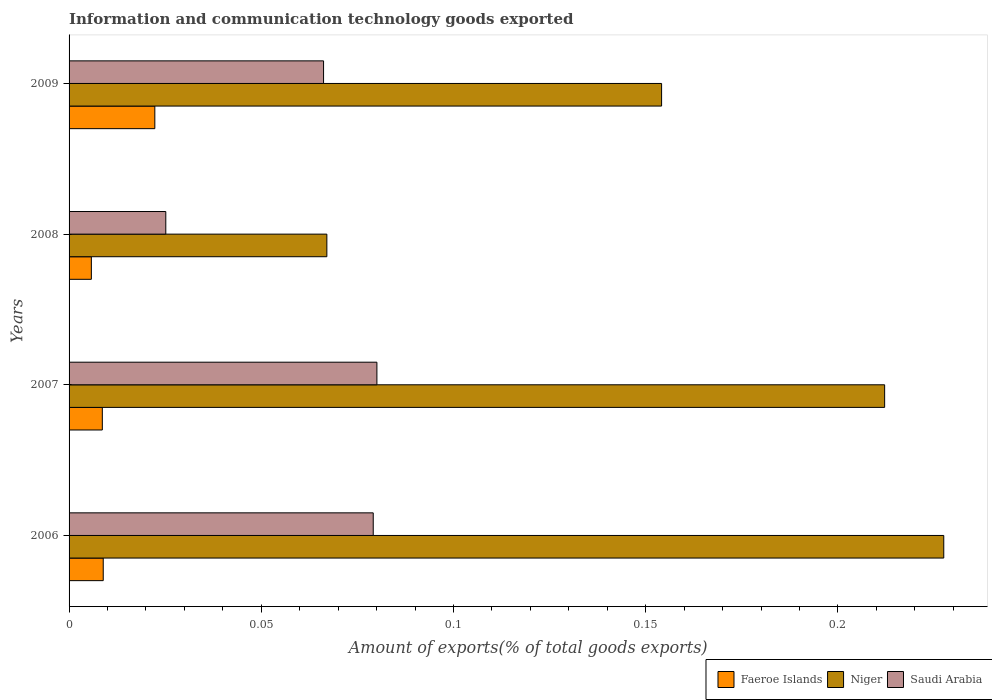How many different coloured bars are there?
Give a very brief answer. 3. Are the number of bars per tick equal to the number of legend labels?
Ensure brevity in your answer.  Yes. Are the number of bars on each tick of the Y-axis equal?
Keep it short and to the point. Yes. What is the label of the 2nd group of bars from the top?
Ensure brevity in your answer.  2008. What is the amount of goods exported in Niger in 2008?
Keep it short and to the point. 0.07. Across all years, what is the maximum amount of goods exported in Niger?
Your response must be concise. 0.23. Across all years, what is the minimum amount of goods exported in Niger?
Keep it short and to the point. 0.07. In which year was the amount of goods exported in Saudi Arabia minimum?
Give a very brief answer. 2008. What is the total amount of goods exported in Saudi Arabia in the graph?
Provide a short and direct response. 0.25. What is the difference between the amount of goods exported in Saudi Arabia in 2007 and that in 2009?
Your answer should be very brief. 0.01. What is the difference between the amount of goods exported in Niger in 2009 and the amount of goods exported in Faeroe Islands in 2007?
Your answer should be very brief. 0.15. What is the average amount of goods exported in Niger per year?
Your answer should be very brief. 0.17. In the year 2007, what is the difference between the amount of goods exported in Niger and amount of goods exported in Saudi Arabia?
Keep it short and to the point. 0.13. In how many years, is the amount of goods exported in Saudi Arabia greater than 0.07 %?
Offer a terse response. 2. What is the ratio of the amount of goods exported in Saudi Arabia in 2006 to that in 2009?
Make the answer very short. 1.2. What is the difference between the highest and the second highest amount of goods exported in Niger?
Make the answer very short. 0.02. What is the difference between the highest and the lowest amount of goods exported in Faeroe Islands?
Make the answer very short. 0.02. In how many years, is the amount of goods exported in Niger greater than the average amount of goods exported in Niger taken over all years?
Provide a succinct answer. 2. Is the sum of the amount of goods exported in Niger in 2006 and 2007 greater than the maximum amount of goods exported in Saudi Arabia across all years?
Your answer should be compact. Yes. What does the 3rd bar from the top in 2008 represents?
Give a very brief answer. Faeroe Islands. What does the 1st bar from the bottom in 2007 represents?
Provide a short and direct response. Faeroe Islands. Is it the case that in every year, the sum of the amount of goods exported in Faeroe Islands and amount of goods exported in Niger is greater than the amount of goods exported in Saudi Arabia?
Provide a succinct answer. Yes. How many bars are there?
Offer a very short reply. 12. Are all the bars in the graph horizontal?
Keep it short and to the point. Yes. Are the values on the major ticks of X-axis written in scientific E-notation?
Keep it short and to the point. No. What is the title of the graph?
Ensure brevity in your answer.  Information and communication technology goods exported. Does "Kosovo" appear as one of the legend labels in the graph?
Your answer should be very brief. No. What is the label or title of the X-axis?
Your answer should be very brief. Amount of exports(% of total goods exports). What is the label or title of the Y-axis?
Provide a short and direct response. Years. What is the Amount of exports(% of total goods exports) in Faeroe Islands in 2006?
Your answer should be very brief. 0.01. What is the Amount of exports(% of total goods exports) of Niger in 2006?
Make the answer very short. 0.23. What is the Amount of exports(% of total goods exports) of Saudi Arabia in 2006?
Provide a succinct answer. 0.08. What is the Amount of exports(% of total goods exports) in Faeroe Islands in 2007?
Your answer should be very brief. 0.01. What is the Amount of exports(% of total goods exports) in Niger in 2007?
Your answer should be compact. 0.21. What is the Amount of exports(% of total goods exports) in Saudi Arabia in 2007?
Your answer should be compact. 0.08. What is the Amount of exports(% of total goods exports) in Faeroe Islands in 2008?
Keep it short and to the point. 0.01. What is the Amount of exports(% of total goods exports) in Niger in 2008?
Give a very brief answer. 0.07. What is the Amount of exports(% of total goods exports) of Saudi Arabia in 2008?
Offer a very short reply. 0.03. What is the Amount of exports(% of total goods exports) in Faeroe Islands in 2009?
Your answer should be compact. 0.02. What is the Amount of exports(% of total goods exports) of Niger in 2009?
Make the answer very short. 0.15. What is the Amount of exports(% of total goods exports) of Saudi Arabia in 2009?
Offer a very short reply. 0.07. Across all years, what is the maximum Amount of exports(% of total goods exports) of Faeroe Islands?
Your response must be concise. 0.02. Across all years, what is the maximum Amount of exports(% of total goods exports) of Niger?
Ensure brevity in your answer.  0.23. Across all years, what is the maximum Amount of exports(% of total goods exports) in Saudi Arabia?
Provide a succinct answer. 0.08. Across all years, what is the minimum Amount of exports(% of total goods exports) in Faeroe Islands?
Your response must be concise. 0.01. Across all years, what is the minimum Amount of exports(% of total goods exports) in Niger?
Offer a terse response. 0.07. Across all years, what is the minimum Amount of exports(% of total goods exports) in Saudi Arabia?
Your answer should be compact. 0.03. What is the total Amount of exports(% of total goods exports) in Faeroe Islands in the graph?
Offer a very short reply. 0.05. What is the total Amount of exports(% of total goods exports) of Niger in the graph?
Keep it short and to the point. 0.66. What is the total Amount of exports(% of total goods exports) of Saudi Arabia in the graph?
Your answer should be compact. 0.25. What is the difference between the Amount of exports(% of total goods exports) of Niger in 2006 and that in 2007?
Your answer should be very brief. 0.02. What is the difference between the Amount of exports(% of total goods exports) in Saudi Arabia in 2006 and that in 2007?
Your response must be concise. -0. What is the difference between the Amount of exports(% of total goods exports) of Faeroe Islands in 2006 and that in 2008?
Your response must be concise. 0. What is the difference between the Amount of exports(% of total goods exports) of Niger in 2006 and that in 2008?
Ensure brevity in your answer.  0.16. What is the difference between the Amount of exports(% of total goods exports) of Saudi Arabia in 2006 and that in 2008?
Your answer should be compact. 0.05. What is the difference between the Amount of exports(% of total goods exports) of Faeroe Islands in 2006 and that in 2009?
Your response must be concise. -0.01. What is the difference between the Amount of exports(% of total goods exports) in Niger in 2006 and that in 2009?
Provide a short and direct response. 0.07. What is the difference between the Amount of exports(% of total goods exports) in Saudi Arabia in 2006 and that in 2009?
Your response must be concise. 0.01. What is the difference between the Amount of exports(% of total goods exports) of Faeroe Islands in 2007 and that in 2008?
Keep it short and to the point. 0. What is the difference between the Amount of exports(% of total goods exports) of Niger in 2007 and that in 2008?
Make the answer very short. 0.15. What is the difference between the Amount of exports(% of total goods exports) of Saudi Arabia in 2007 and that in 2008?
Provide a succinct answer. 0.05. What is the difference between the Amount of exports(% of total goods exports) of Faeroe Islands in 2007 and that in 2009?
Your answer should be compact. -0.01. What is the difference between the Amount of exports(% of total goods exports) of Niger in 2007 and that in 2009?
Offer a terse response. 0.06. What is the difference between the Amount of exports(% of total goods exports) in Saudi Arabia in 2007 and that in 2009?
Make the answer very short. 0.01. What is the difference between the Amount of exports(% of total goods exports) of Faeroe Islands in 2008 and that in 2009?
Your response must be concise. -0.02. What is the difference between the Amount of exports(% of total goods exports) of Niger in 2008 and that in 2009?
Keep it short and to the point. -0.09. What is the difference between the Amount of exports(% of total goods exports) in Saudi Arabia in 2008 and that in 2009?
Offer a very short reply. -0.04. What is the difference between the Amount of exports(% of total goods exports) of Faeroe Islands in 2006 and the Amount of exports(% of total goods exports) of Niger in 2007?
Your answer should be compact. -0.2. What is the difference between the Amount of exports(% of total goods exports) in Faeroe Islands in 2006 and the Amount of exports(% of total goods exports) in Saudi Arabia in 2007?
Your answer should be compact. -0.07. What is the difference between the Amount of exports(% of total goods exports) in Niger in 2006 and the Amount of exports(% of total goods exports) in Saudi Arabia in 2007?
Make the answer very short. 0.15. What is the difference between the Amount of exports(% of total goods exports) in Faeroe Islands in 2006 and the Amount of exports(% of total goods exports) in Niger in 2008?
Make the answer very short. -0.06. What is the difference between the Amount of exports(% of total goods exports) of Faeroe Islands in 2006 and the Amount of exports(% of total goods exports) of Saudi Arabia in 2008?
Your response must be concise. -0.02. What is the difference between the Amount of exports(% of total goods exports) in Niger in 2006 and the Amount of exports(% of total goods exports) in Saudi Arabia in 2008?
Your answer should be compact. 0.2. What is the difference between the Amount of exports(% of total goods exports) in Faeroe Islands in 2006 and the Amount of exports(% of total goods exports) in Niger in 2009?
Your answer should be compact. -0.15. What is the difference between the Amount of exports(% of total goods exports) of Faeroe Islands in 2006 and the Amount of exports(% of total goods exports) of Saudi Arabia in 2009?
Provide a short and direct response. -0.06. What is the difference between the Amount of exports(% of total goods exports) of Niger in 2006 and the Amount of exports(% of total goods exports) of Saudi Arabia in 2009?
Provide a short and direct response. 0.16. What is the difference between the Amount of exports(% of total goods exports) in Faeroe Islands in 2007 and the Amount of exports(% of total goods exports) in Niger in 2008?
Your answer should be compact. -0.06. What is the difference between the Amount of exports(% of total goods exports) in Faeroe Islands in 2007 and the Amount of exports(% of total goods exports) in Saudi Arabia in 2008?
Provide a short and direct response. -0.02. What is the difference between the Amount of exports(% of total goods exports) in Niger in 2007 and the Amount of exports(% of total goods exports) in Saudi Arabia in 2008?
Your response must be concise. 0.19. What is the difference between the Amount of exports(% of total goods exports) in Faeroe Islands in 2007 and the Amount of exports(% of total goods exports) in Niger in 2009?
Keep it short and to the point. -0.15. What is the difference between the Amount of exports(% of total goods exports) in Faeroe Islands in 2007 and the Amount of exports(% of total goods exports) in Saudi Arabia in 2009?
Give a very brief answer. -0.06. What is the difference between the Amount of exports(% of total goods exports) of Niger in 2007 and the Amount of exports(% of total goods exports) of Saudi Arabia in 2009?
Ensure brevity in your answer.  0.15. What is the difference between the Amount of exports(% of total goods exports) of Faeroe Islands in 2008 and the Amount of exports(% of total goods exports) of Niger in 2009?
Make the answer very short. -0.15. What is the difference between the Amount of exports(% of total goods exports) in Faeroe Islands in 2008 and the Amount of exports(% of total goods exports) in Saudi Arabia in 2009?
Ensure brevity in your answer.  -0.06. What is the difference between the Amount of exports(% of total goods exports) of Niger in 2008 and the Amount of exports(% of total goods exports) of Saudi Arabia in 2009?
Your answer should be compact. 0. What is the average Amount of exports(% of total goods exports) of Faeroe Islands per year?
Provide a succinct answer. 0.01. What is the average Amount of exports(% of total goods exports) of Niger per year?
Your response must be concise. 0.17. What is the average Amount of exports(% of total goods exports) of Saudi Arabia per year?
Offer a terse response. 0.06. In the year 2006, what is the difference between the Amount of exports(% of total goods exports) of Faeroe Islands and Amount of exports(% of total goods exports) of Niger?
Keep it short and to the point. -0.22. In the year 2006, what is the difference between the Amount of exports(% of total goods exports) of Faeroe Islands and Amount of exports(% of total goods exports) of Saudi Arabia?
Provide a succinct answer. -0.07. In the year 2006, what is the difference between the Amount of exports(% of total goods exports) of Niger and Amount of exports(% of total goods exports) of Saudi Arabia?
Your answer should be compact. 0.15. In the year 2007, what is the difference between the Amount of exports(% of total goods exports) in Faeroe Islands and Amount of exports(% of total goods exports) in Niger?
Offer a terse response. -0.2. In the year 2007, what is the difference between the Amount of exports(% of total goods exports) in Faeroe Islands and Amount of exports(% of total goods exports) in Saudi Arabia?
Make the answer very short. -0.07. In the year 2007, what is the difference between the Amount of exports(% of total goods exports) of Niger and Amount of exports(% of total goods exports) of Saudi Arabia?
Make the answer very short. 0.13. In the year 2008, what is the difference between the Amount of exports(% of total goods exports) in Faeroe Islands and Amount of exports(% of total goods exports) in Niger?
Your response must be concise. -0.06. In the year 2008, what is the difference between the Amount of exports(% of total goods exports) of Faeroe Islands and Amount of exports(% of total goods exports) of Saudi Arabia?
Offer a very short reply. -0.02. In the year 2008, what is the difference between the Amount of exports(% of total goods exports) of Niger and Amount of exports(% of total goods exports) of Saudi Arabia?
Offer a terse response. 0.04. In the year 2009, what is the difference between the Amount of exports(% of total goods exports) in Faeroe Islands and Amount of exports(% of total goods exports) in Niger?
Offer a terse response. -0.13. In the year 2009, what is the difference between the Amount of exports(% of total goods exports) of Faeroe Islands and Amount of exports(% of total goods exports) of Saudi Arabia?
Provide a succinct answer. -0.04. In the year 2009, what is the difference between the Amount of exports(% of total goods exports) of Niger and Amount of exports(% of total goods exports) of Saudi Arabia?
Ensure brevity in your answer.  0.09. What is the ratio of the Amount of exports(% of total goods exports) of Faeroe Islands in 2006 to that in 2007?
Provide a short and direct response. 1.03. What is the ratio of the Amount of exports(% of total goods exports) of Niger in 2006 to that in 2007?
Your answer should be compact. 1.07. What is the ratio of the Amount of exports(% of total goods exports) of Faeroe Islands in 2006 to that in 2008?
Offer a very short reply. 1.53. What is the ratio of the Amount of exports(% of total goods exports) in Niger in 2006 to that in 2008?
Offer a very short reply. 3.39. What is the ratio of the Amount of exports(% of total goods exports) of Saudi Arabia in 2006 to that in 2008?
Provide a short and direct response. 3.14. What is the ratio of the Amount of exports(% of total goods exports) of Faeroe Islands in 2006 to that in 2009?
Provide a succinct answer. 0.4. What is the ratio of the Amount of exports(% of total goods exports) of Niger in 2006 to that in 2009?
Ensure brevity in your answer.  1.48. What is the ratio of the Amount of exports(% of total goods exports) of Saudi Arabia in 2006 to that in 2009?
Provide a succinct answer. 1.2. What is the ratio of the Amount of exports(% of total goods exports) of Faeroe Islands in 2007 to that in 2008?
Provide a short and direct response. 1.49. What is the ratio of the Amount of exports(% of total goods exports) of Niger in 2007 to that in 2008?
Offer a very short reply. 3.16. What is the ratio of the Amount of exports(% of total goods exports) in Saudi Arabia in 2007 to that in 2008?
Provide a succinct answer. 3.18. What is the ratio of the Amount of exports(% of total goods exports) of Faeroe Islands in 2007 to that in 2009?
Ensure brevity in your answer.  0.39. What is the ratio of the Amount of exports(% of total goods exports) of Niger in 2007 to that in 2009?
Ensure brevity in your answer.  1.38. What is the ratio of the Amount of exports(% of total goods exports) in Saudi Arabia in 2007 to that in 2009?
Provide a succinct answer. 1.21. What is the ratio of the Amount of exports(% of total goods exports) of Faeroe Islands in 2008 to that in 2009?
Keep it short and to the point. 0.26. What is the ratio of the Amount of exports(% of total goods exports) in Niger in 2008 to that in 2009?
Provide a succinct answer. 0.44. What is the ratio of the Amount of exports(% of total goods exports) of Saudi Arabia in 2008 to that in 2009?
Offer a very short reply. 0.38. What is the difference between the highest and the second highest Amount of exports(% of total goods exports) in Faeroe Islands?
Make the answer very short. 0.01. What is the difference between the highest and the second highest Amount of exports(% of total goods exports) in Niger?
Give a very brief answer. 0.02. What is the difference between the highest and the lowest Amount of exports(% of total goods exports) in Faeroe Islands?
Make the answer very short. 0.02. What is the difference between the highest and the lowest Amount of exports(% of total goods exports) in Niger?
Ensure brevity in your answer.  0.16. What is the difference between the highest and the lowest Amount of exports(% of total goods exports) of Saudi Arabia?
Offer a terse response. 0.05. 